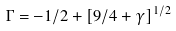Convert formula to latex. <formula><loc_0><loc_0><loc_500><loc_500>\Gamma = - 1 / 2 + [ 9 / 4 + \gamma ] ^ { 1 / 2 }</formula> 